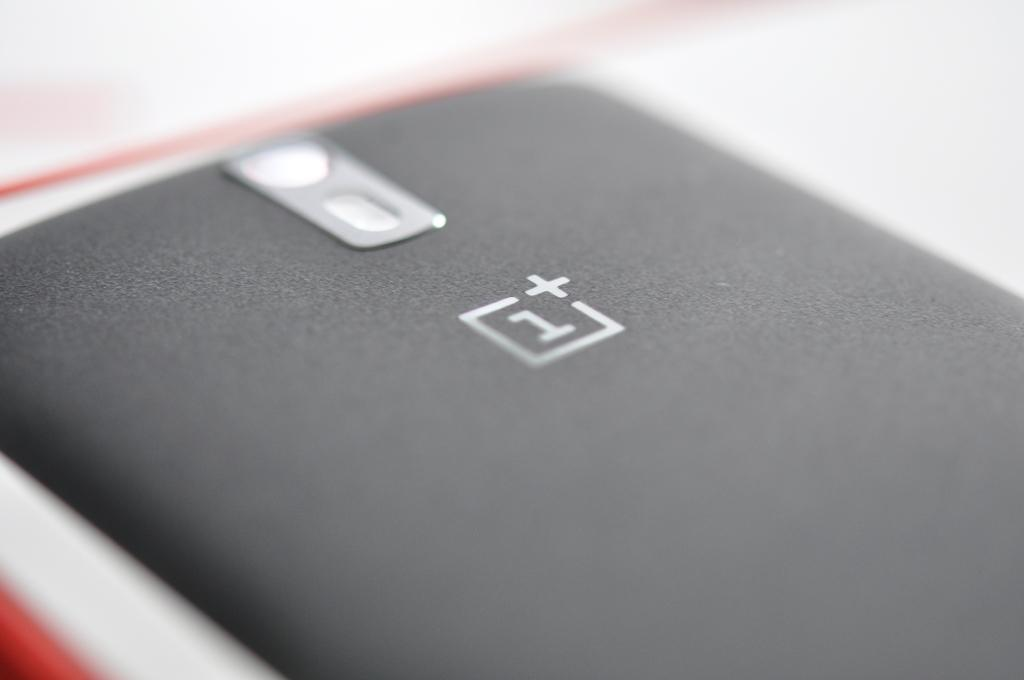<image>
Offer a succinct explanation of the picture presented. the back of a phone that says 1+ on it 